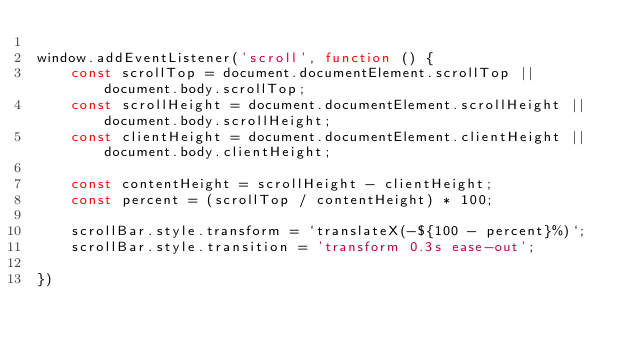<code> <loc_0><loc_0><loc_500><loc_500><_JavaScript_>
window.addEventListener('scroll', function () {
    const scrollTop = document.documentElement.scrollTop || document.body.scrollTop;
    const scrollHeight = document.documentElement.scrollHeight || document.body.scrollHeight;
    const clientHeight = document.documentElement.clientHeight || document.body.clientHeight;

    const contentHeight = scrollHeight - clientHeight;
    const percent = (scrollTop / contentHeight) * 100;

    scrollBar.style.transform = `translateX(-${100 - percent}%)`;
    scrollBar.style.transition = 'transform 0.3s ease-out';
    
})
</code> 